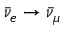Convert formula to latex. <formula><loc_0><loc_0><loc_500><loc_500>\bar { \nu } _ { e } \rightarrow \bar { \nu } _ { \mu }</formula> 